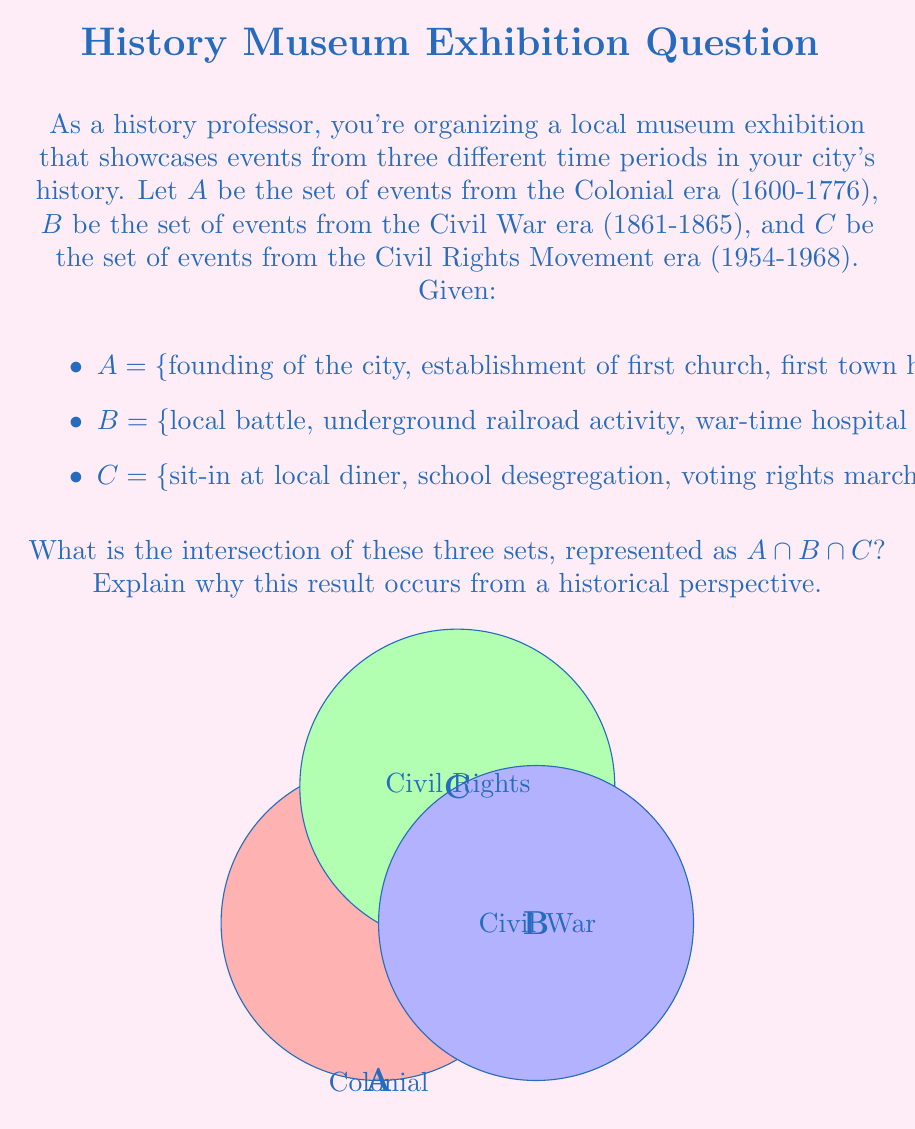Provide a solution to this math problem. To determine the intersection of sets A, B, and C, we need to identify elements that are common to all three sets. Let's approach this step-by-step:

1) First, let's examine each set individually:
   A = {founding of the city, establishment of first church, first town hall meeting, creation of local militia}
   B = {local battle, underground railroad activity, war-time hospital established, emancipation celebration}
   C = {sit-in at local diner, school desegregation, voting rights march, fair housing act protest}

2) Now, let's look for any elements that appear in all three sets:
   - There are no elements that appear in all three sets.

3) From a historical perspective, this result is not surprising:
   - The Colonial era (Set A) predates both the Civil War era (Set B) and the Civil Rights Movement era (Set C) by a significant margin.
   - The Civil War era (Set B) and the Civil Rights Movement era (Set C) are also separated by about 90 years.
   - Each of these eras had distinct characteristics and events that were unique to their time periods.

4) The lack of intersection can be represented mathematically as:

   $A \cap B \cap C = \emptyset$

   Where $\emptyset$ represents the empty set.

5) This empty intersection illustrates the distinct nature of these historical periods and emphasizes how events and issues evolved over time in the city's history.
Answer: $A \cap B \cap C = \emptyset$ 